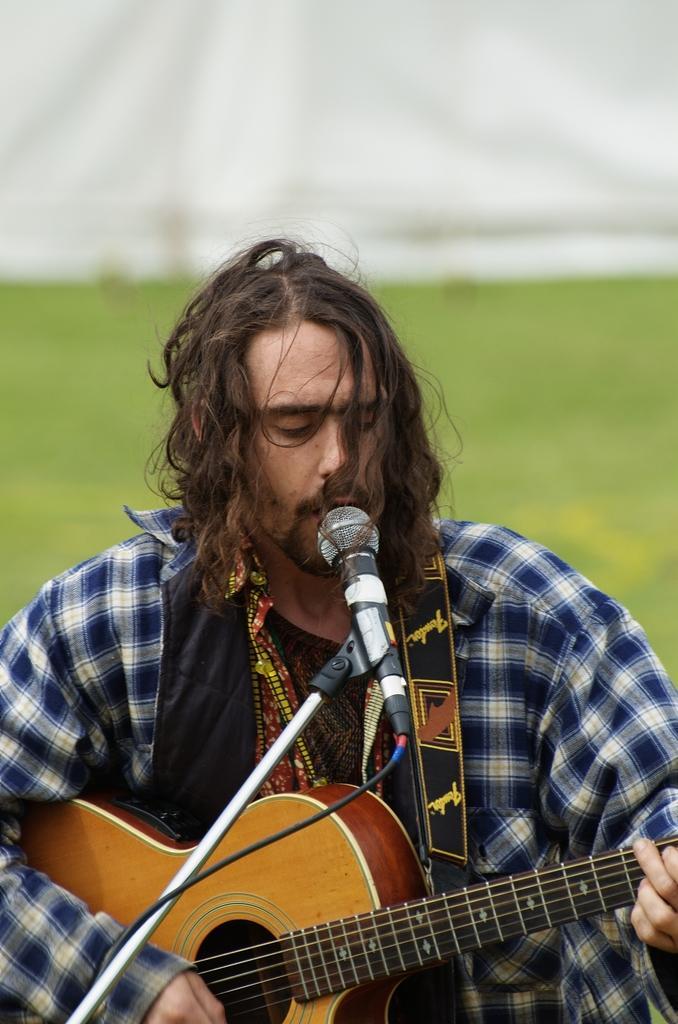Can you describe this image briefly? The person is playing guitar. He is holding guitar. His singing. we can see in the background there is a greenery part. 